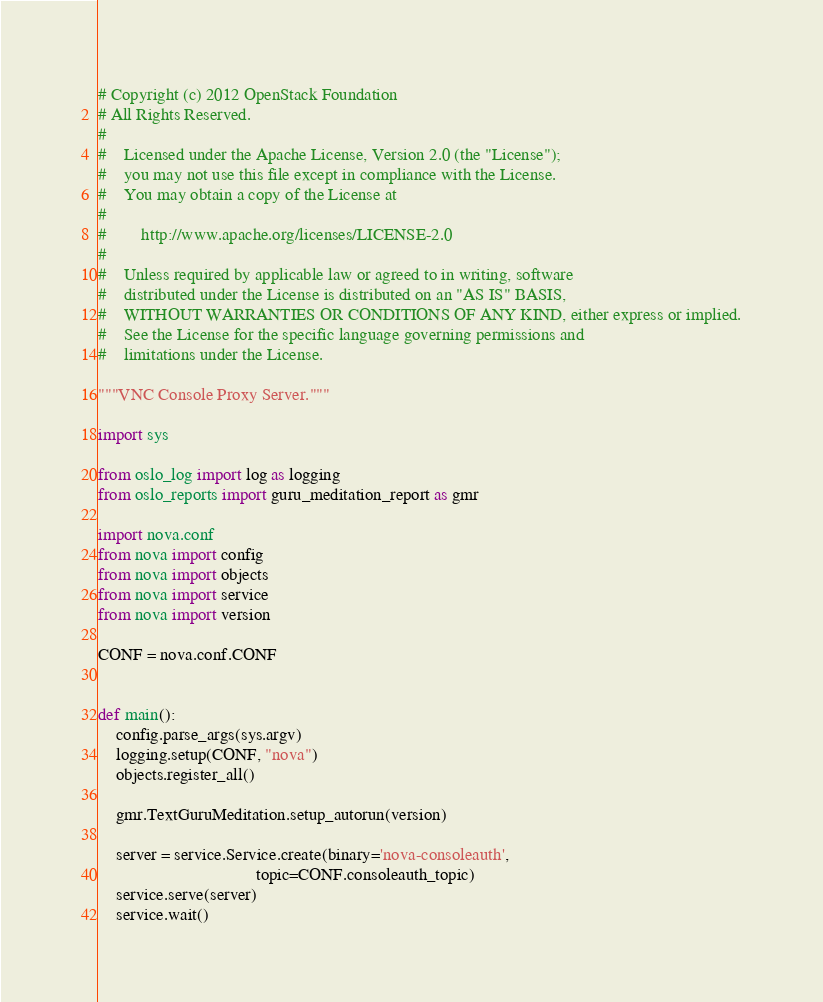<code> <loc_0><loc_0><loc_500><loc_500><_Python_># Copyright (c) 2012 OpenStack Foundation
# All Rights Reserved.
#
#    Licensed under the Apache License, Version 2.0 (the "License");
#    you may not use this file except in compliance with the License.
#    You may obtain a copy of the License at
#
#        http://www.apache.org/licenses/LICENSE-2.0
#
#    Unless required by applicable law or agreed to in writing, software
#    distributed under the License is distributed on an "AS IS" BASIS,
#    WITHOUT WARRANTIES OR CONDITIONS OF ANY KIND, either express or implied.
#    See the License for the specific language governing permissions and
#    limitations under the License.

"""VNC Console Proxy Server."""

import sys

from oslo_log import log as logging
from oslo_reports import guru_meditation_report as gmr

import nova.conf
from nova import config
from nova import objects
from nova import service
from nova import version

CONF = nova.conf.CONF


def main():
    config.parse_args(sys.argv)
    logging.setup(CONF, "nova")
    objects.register_all()

    gmr.TextGuruMeditation.setup_autorun(version)

    server = service.Service.create(binary='nova-consoleauth',
                                    topic=CONF.consoleauth_topic)
    service.serve(server)
    service.wait()
</code> 